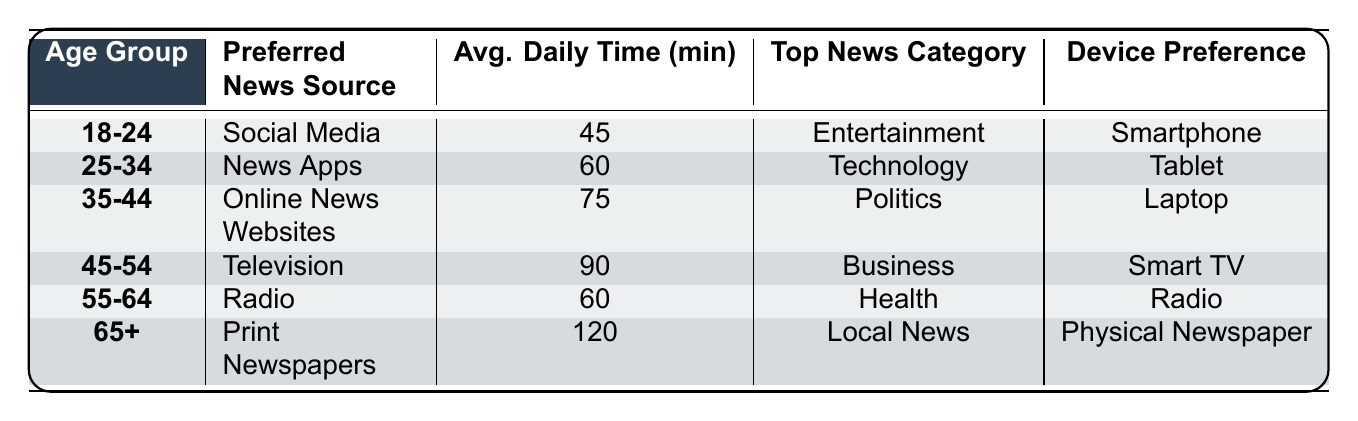What is the preferred news source for the 35-44 age group? According to the table, the preferred news source for the 35-44 age group is "Online News Websites."
Answer: Online News Websites How much average daily time do people aged 45-54 spend on news? The table shows that individuals in the 45-54 age group spend an average of 90 minutes daily on news consumption.
Answer: 90 minutes Which age group prefers radio as their news source? The table indicates that the 55-64 age group prefers radio as their news source.
Answer: 55-64 Is the average daily time for news consumption higher in the 65+ age group compared to the 18-24 age group? The average daily time for the 65+ age group is 120 minutes, while for the 18-24 age group, it is 45 minutes. Since 120 is greater than 45, the statement is true.
Answer: Yes What is the sum of the average daily time spent on news for the age groups 25-34 and 35-44? From the table, the average daily time for the 25-34 age group is 60 minutes and for 35-44 is 75 minutes. The sum is 60 + 75 = 135 minutes.
Answer: 135 minutes Which device is most commonly preferred by people aged 45-54 for news consumption? The table states that individuals aged 45-54 prefer a Smart TV as their device for news consumption.
Answer: Smart TV What is the top news category for the 25-34 age group? The top news category for the 25-34 age group, as stated in the table, is Technology.
Answer: Technology Are News Apps the preferred source for the age group 18-24? The table indicates that Social Media is the preferred source for the 18-24 age group, not News Apps. Therefore, the statement is false.
Answer: No What is the average time difference in news consumption between the 55-64 and 65+ age groups? The average daily time for the 55-64 age group is 60 minutes, and for the 65+ age group, it is 120 minutes. The difference is 120 - 60 = 60 minutes.
Answer: 60 minutes 